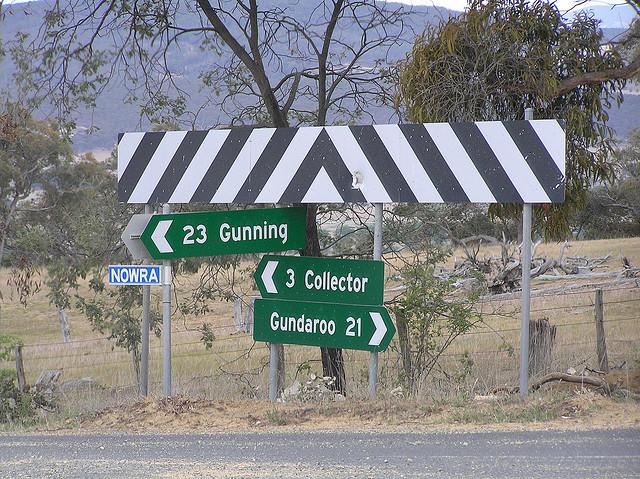How far is Bennett?
Answer briefly. There is no bennett. Are Gunning and Gundaroo the same direction?
Give a very brief answer. No. Which way is the arrow pointing?
Write a very short answer. Left. Is this photo taken in the city?
Concise answer only. No. How far to Collector?
Give a very brief answer. 3. 